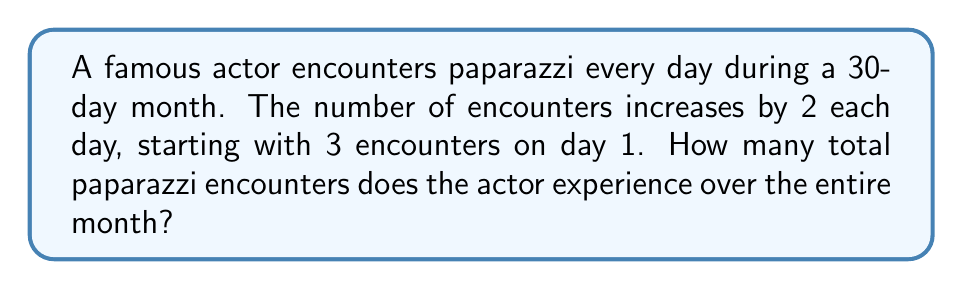Show me your answer to this math problem. Let's approach this step-by-step:

1) We have an arithmetic sequence where:
   - The first term, $a_1 = 3$
   - The common difference, $d = 2$
   - The number of terms, $n = 30$ (for a 30-day month)

2) The last term of the sequence can be calculated using the formula:
   $a_n = a_1 + (n-1)d$
   $a_{30} = 3 + (30-1)2 = 3 + 58 = 61$

3) For an arithmetic sequence, the sum of all terms is given by:
   $S_n = \frac{n}{2}(a_1 + a_n)$

4) Substituting our values:
   $S_{30} = \frac{30}{2}(3 + 61)$
   $S_{30} = 15(64)$
   $S_{30} = 960$

Therefore, the total number of paparazzi encounters over the entire month is 960.
Answer: 960 encounters 